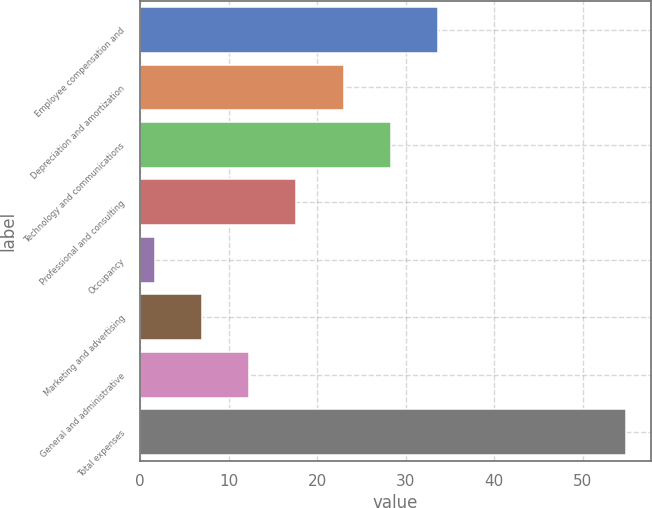<chart> <loc_0><loc_0><loc_500><loc_500><bar_chart><fcel>Employee compensation and<fcel>Depreciation and amortization<fcel>Technology and communications<fcel>Professional and consulting<fcel>Occupancy<fcel>Marketing and advertising<fcel>General and administrative<fcel>Total expenses<nl><fcel>33.62<fcel>22.98<fcel>28.3<fcel>17.66<fcel>1.7<fcel>7.02<fcel>12.34<fcel>54.9<nl></chart> 